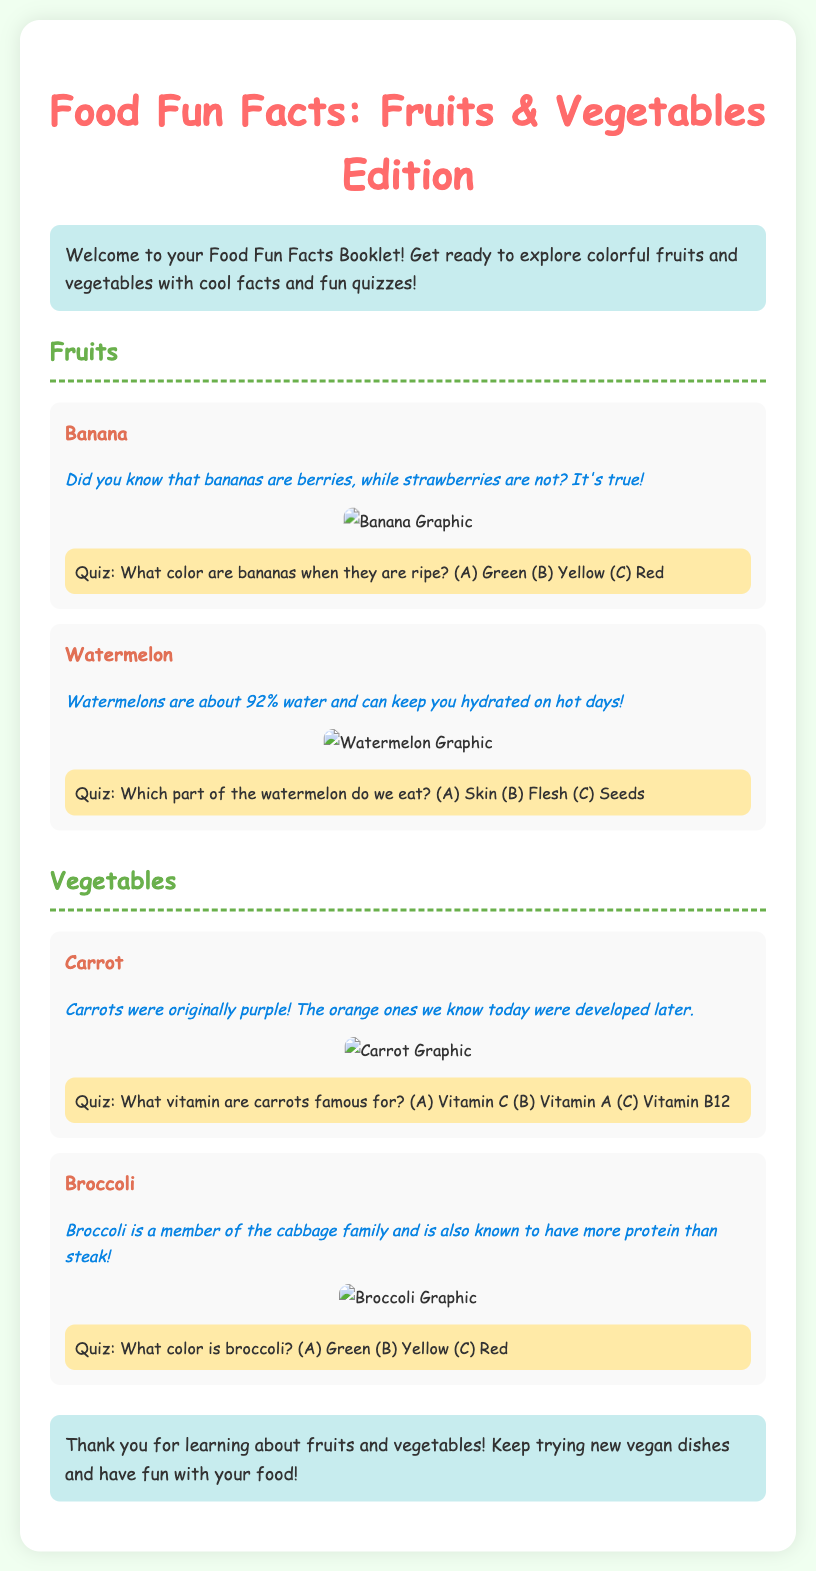What fruit is considered a berry? The document states that bananas are classified as berries, while strawberries are not.
Answer: Bananas What percentage of water is watermelon? According to the document, watermelons are about 92% water.
Answer: 92% What vitamin are carrots famous for? The document indicates that carrots are particularly known for being high in Vitamin A.
Answer: Vitamin A Which color of broccoli is mentioned in the document? The section on broccoli specifically refers to its color as green.
Answer: Green What was the original color of carrots? The document mentions that carrots were originally purple before the orange ones were developed.
Answer: Purple What fact connects broccoli and steak? The document states that broccoli has more protein than steak, making a special comparison.
Answer: More protein What type of facts does the booklet emphasize? The document highlights interesting and fun facts about fruits and vegetables as a key element.
Answer: Fun facts What are the two main sections of the booklet? The document is divided into sections focusing on Fruits and Vegetables specifically.
Answer: Fruits and Vegetables What type of quiz question is included about bananas? There is a quiz related to the color of ripe bananas, testing knowledge about this fruit.
Answer: Color of ripe bananas 